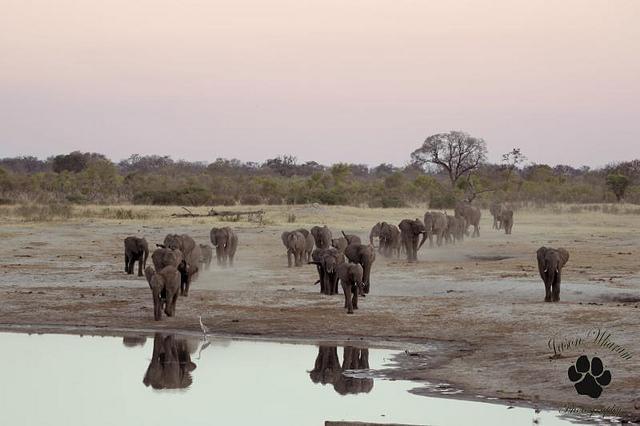How many cars are in the crosswalk?
Give a very brief answer. 0. 